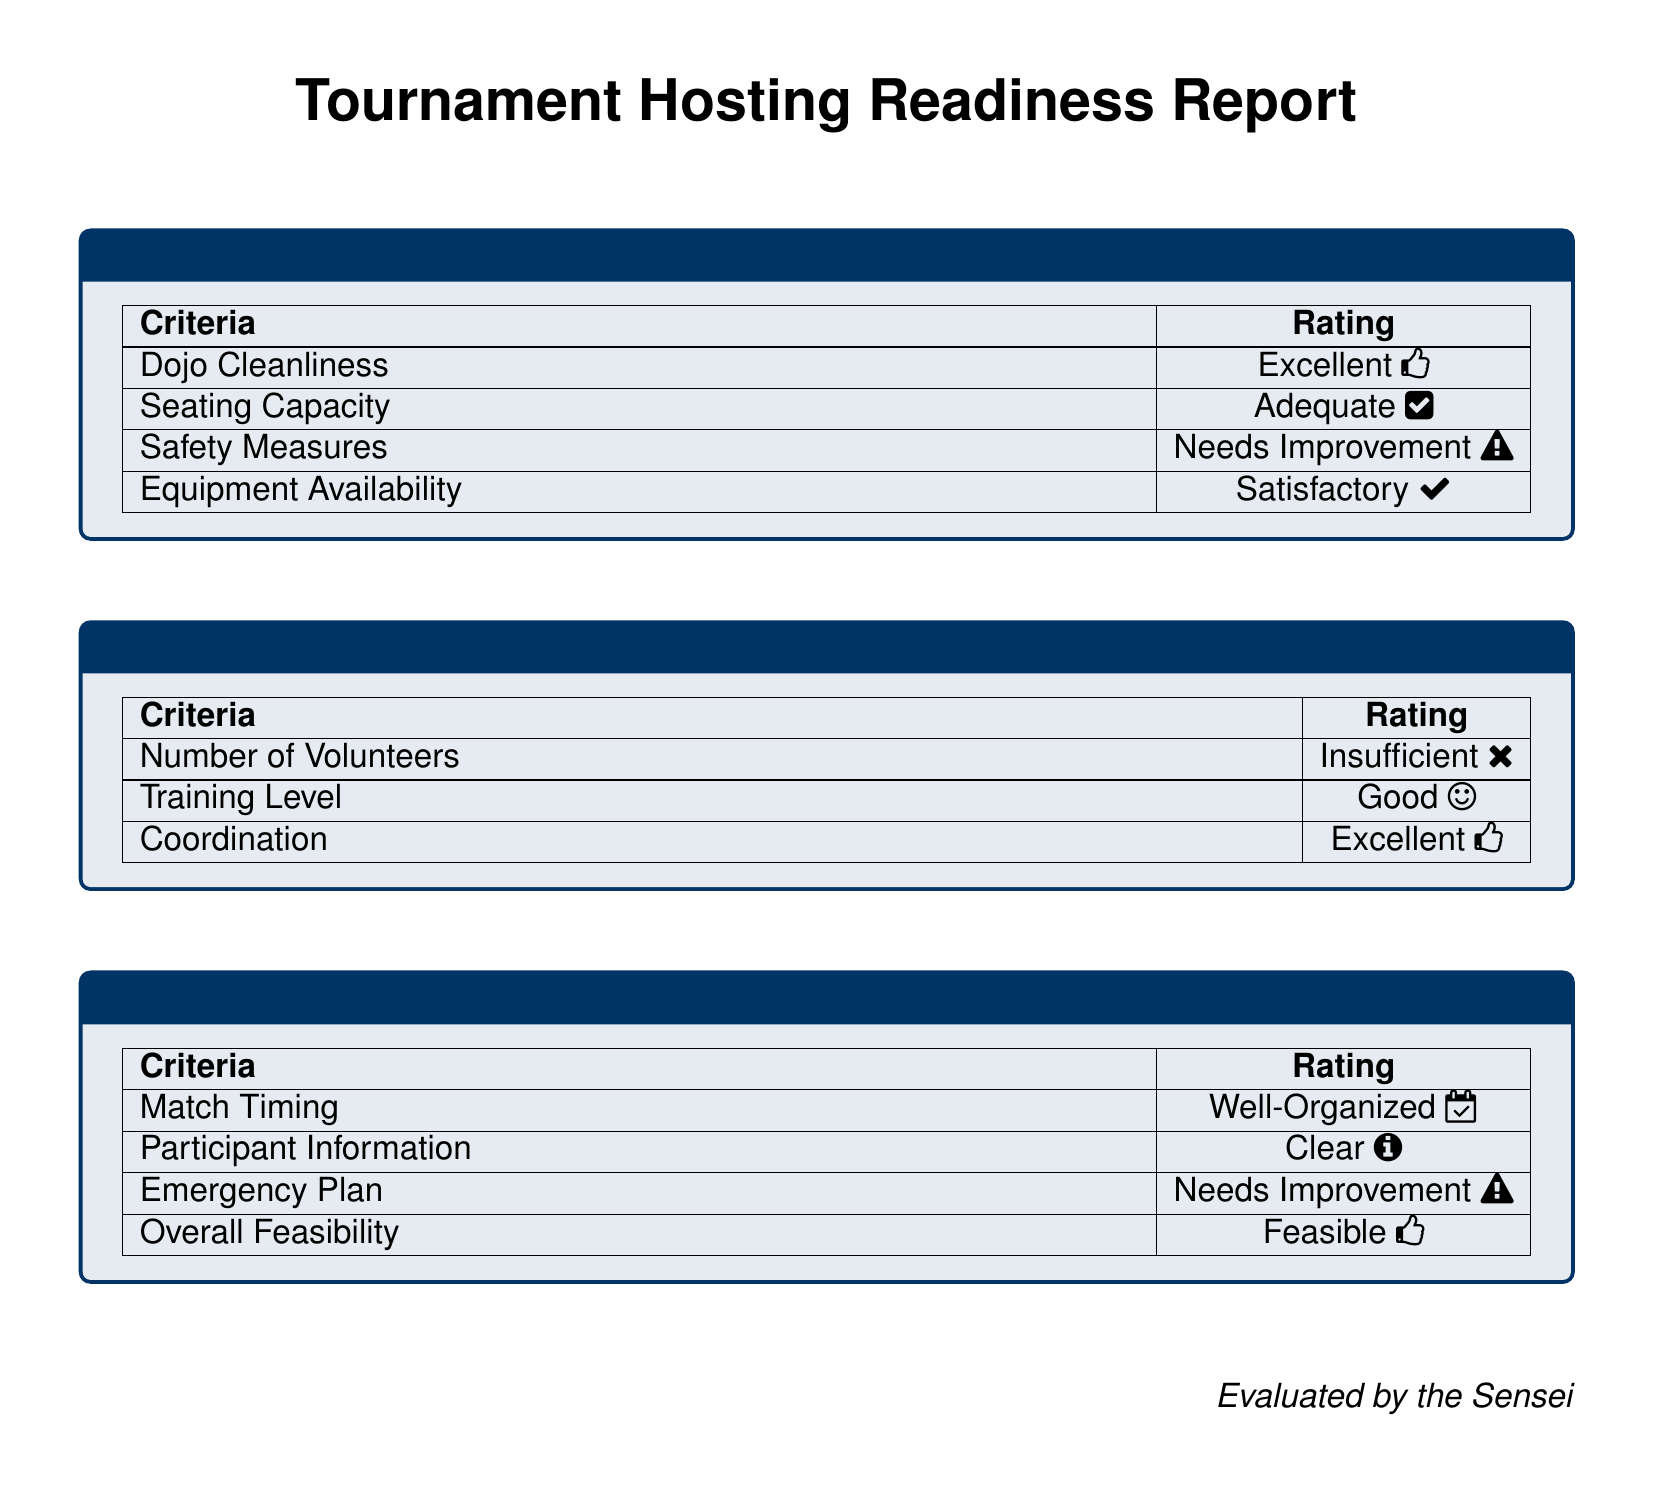What is the rating for Dojo Cleanliness? The document states that the rating for Dojo Cleanliness is "Excellent."
Answer: Excellent What is the availability rating of the equipment? The report mentions that the Equipment Availability rating is "Satisfactory."
Answer: Satisfactory How many volunteers are listed as available? According to the document, the Number of Volunteers is rated as "Insufficient."
Answer: Insufficient What is the condition of the Safety Measures? The report indicates that the Safety Measures rating is "Needs Improvement."
Answer: Needs Improvement What is the rating for Match Timing? The document indicates that the Match Timing is rated as "Well-Organized."
Answer: Well-Organized What does the event schedule say about participant information? The report states that the Participant Information is rated as "Clear."
Answer: Clear Is the overall feasibility of the event considered feasible? The document confirms that the Overall Feasibility is rated as "Feasible."
Answer: Feasible What improvement is needed for the Emergency Plan? The document states that the Emergency Plan needs Improvement.
Answer: Needs Improvement What is the coordination rating of the volunteers? It is rated as "Excellent" according to the report.
Answer: Excellent 